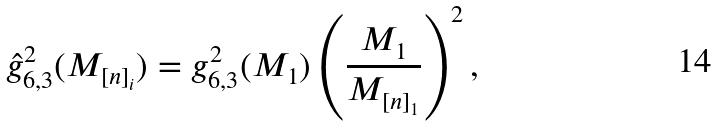<formula> <loc_0><loc_0><loc_500><loc_500>\hat { g } _ { 6 , 3 } ^ { 2 } ( M _ { [ n ] _ { i } } ) = g _ { 6 , 3 } ^ { 2 } ( M _ { 1 } ) \left ( \frac { M _ { 1 } } { M _ { [ n ] _ { 1 } } } \right ) ^ { 2 } ,</formula> 